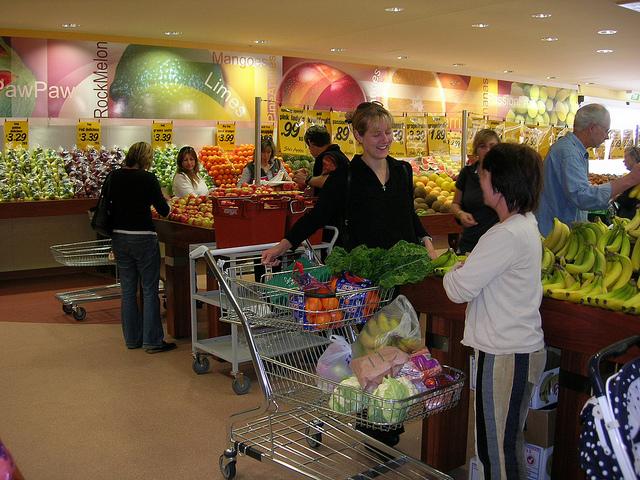Is this a supermarket?
Keep it brief. Yes. Is it bright in there?
Concise answer only. Yes. Are the people shopping for fruits and vegetables?
Keep it brief. Yes. Are the people at an airport?
Write a very short answer. No. 